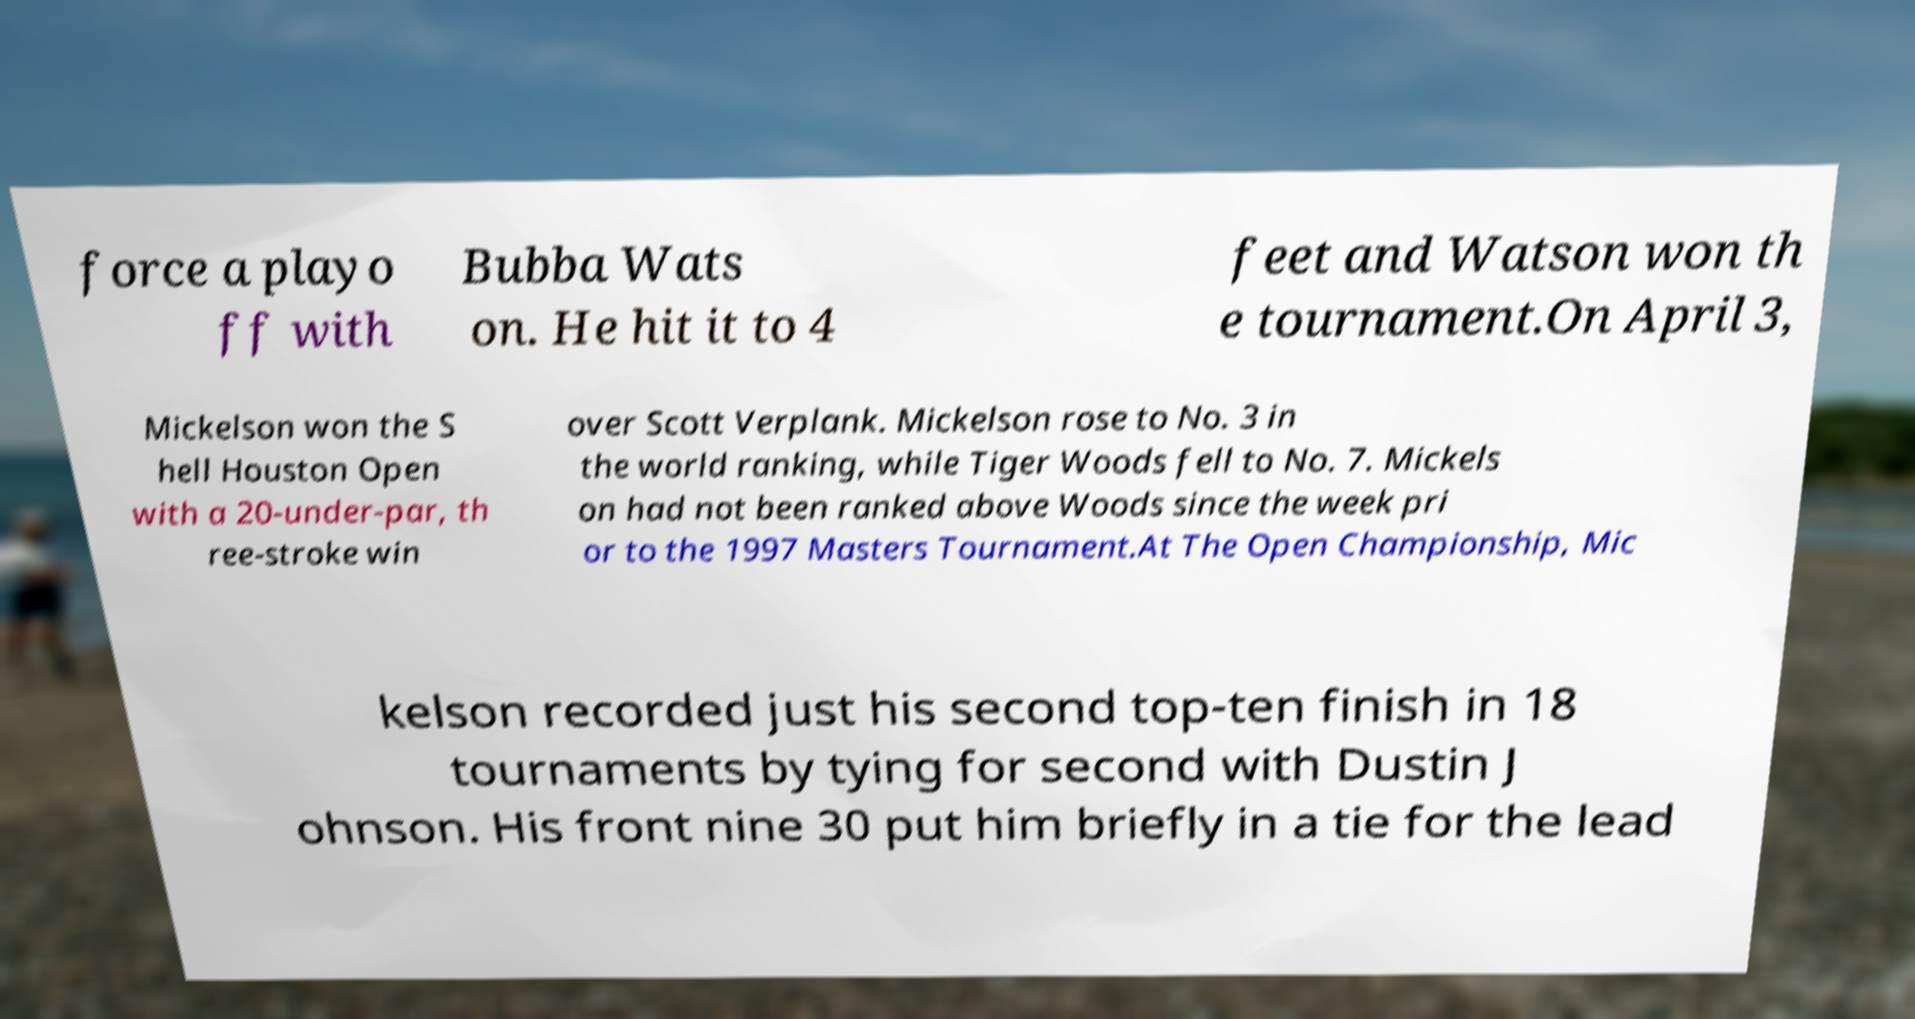Can you accurately transcribe the text from the provided image for me? force a playo ff with Bubba Wats on. He hit it to 4 feet and Watson won th e tournament.On April 3, Mickelson won the S hell Houston Open with a 20-under-par, th ree-stroke win over Scott Verplank. Mickelson rose to No. 3 in the world ranking, while Tiger Woods fell to No. 7. Mickels on had not been ranked above Woods since the week pri or to the 1997 Masters Tournament.At The Open Championship, Mic kelson recorded just his second top-ten finish in 18 tournaments by tying for second with Dustin J ohnson. His front nine 30 put him briefly in a tie for the lead 